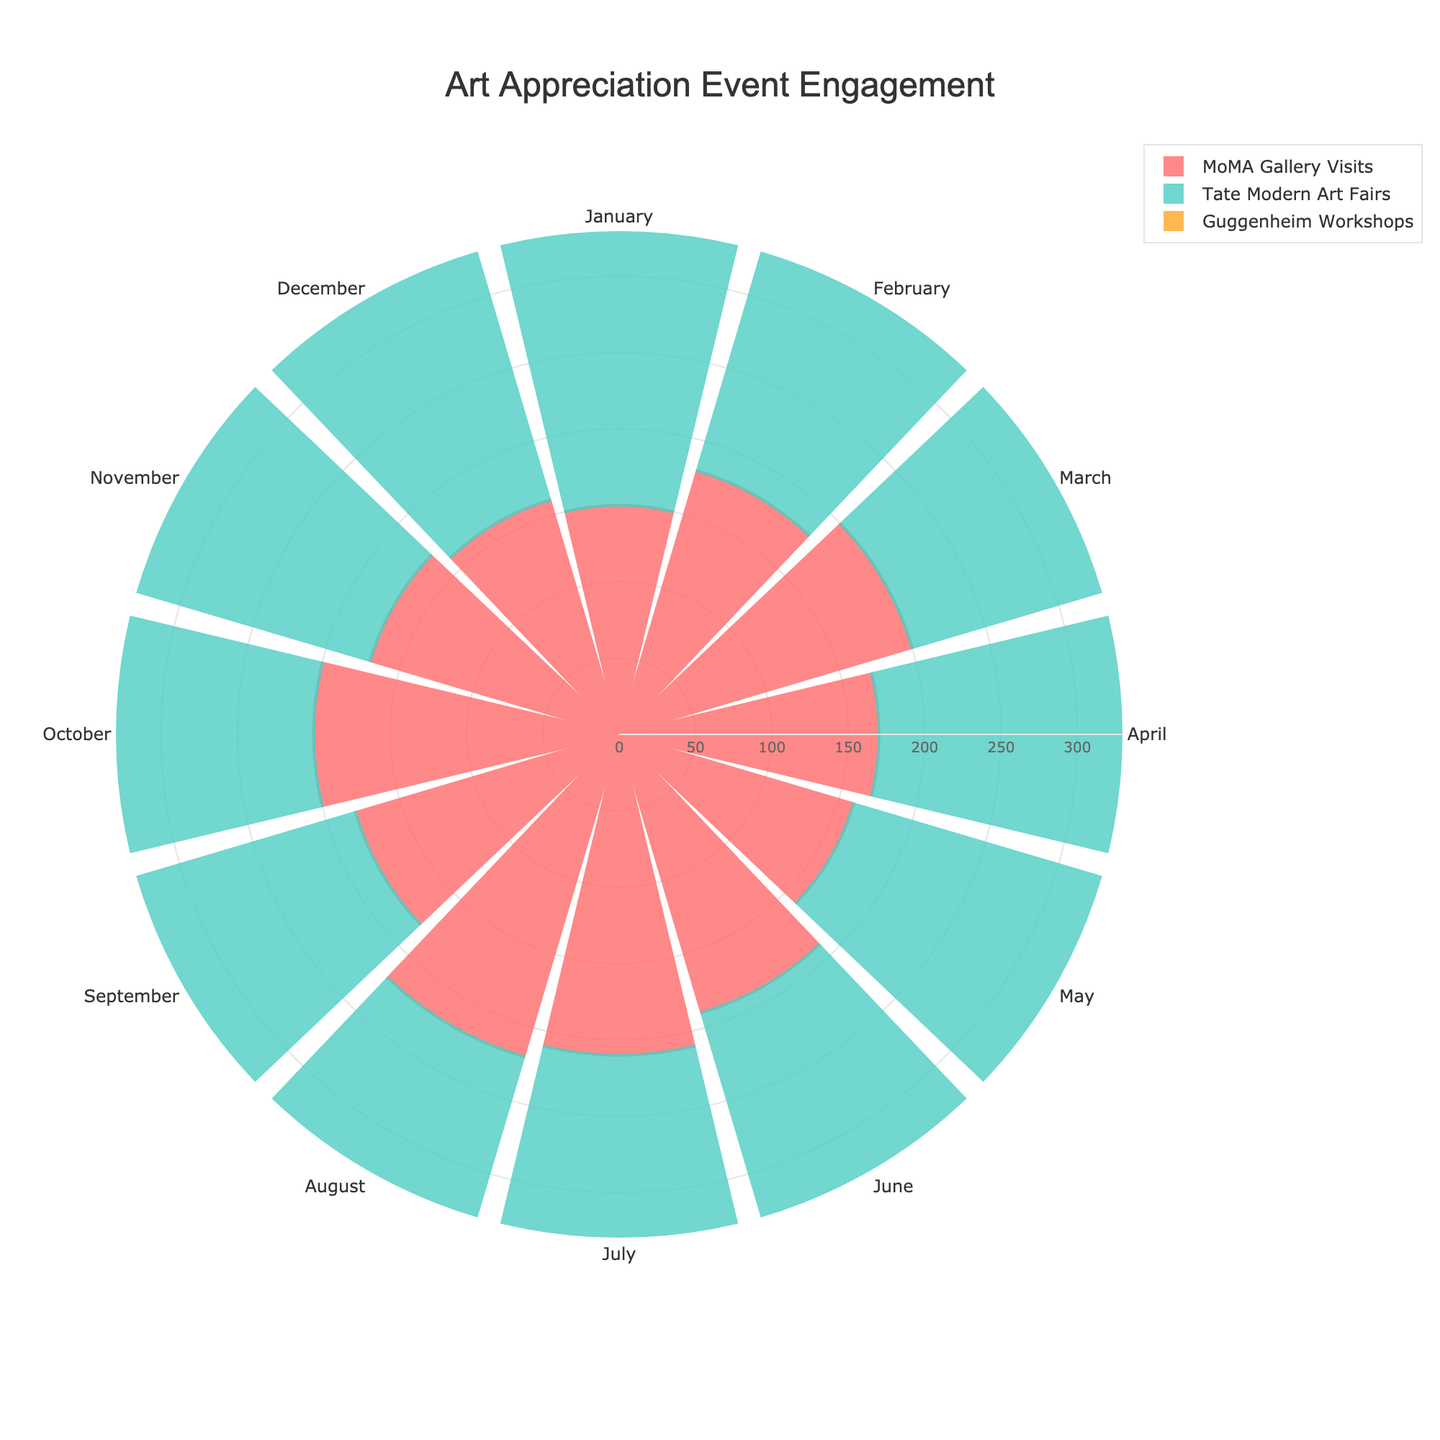1. What is the title of the figure? The title is typically displayed prominently at the top of the figure. In this case, the title is set to "Art Appreciation Event Engagement".
Answer: Art Appreciation Event Engagement 2. Which event had the highest engagement level in August? By looking at the radial distance for August, the longest bar represents the 'Tate Modern Art Fairs'.
Answer: Tate Modern Art Fairs 3. How many groups or categories are there in this rose chart? The rose chart shows three groups: 'MoMA Gallery Visits', 'Tate Modern Art Fairs', and 'Guggenheim Workshops'.
Answer: 3 4. What is the color used to represent 'MoMA Gallery Visits'? The bar representing 'MoMA Gallery Visits' uses a red color.
Answer: Red 5. Which month had the lowest engagement in 'Guggenheim Workshops'? By comparing the radial lengths for each month within the 'Guggenheim Workshops' group, January shows the smallest bar.
Answer: January 6. What is the total engagement level for 'MoMA Gallery Visits' in the first quarter (January to March)? Sum the values for 'MoMA Gallery Visits' in January (150), February (180), and March (200). The total is 150 + 180 + 200 = 530.
Answer: 530 7. During which months did 'Tate Modern Art Fairs' have more than 250 participants? Check the radial lengths for 'Tate Modern Art Fairs' and note the months with bars exceeding 250: April, May, June, July, and August.
Answer: April, May, June, July, August 8. Compare the engagement levels between 'Guggenheim Workshops' and 'MoMA Gallery Visits' in October. Which one is higher, and by how much? 'Guggenheim Workshops' in October has 130 participants, and 'MoMA Gallery Visits' has 200. The difference is 200 - 130 = 70.
Answer: 'MoMA Gallery Visits' by 70 9. What is the average monthly engagement for 'Tate Modern Art Fairs'? Sum the monthly engagements of 'Tate Modern Art Fairs' and divide by 12: (240 + 220 + 230 + 250 + 260 + 280 + 290 + 300 + 270 + 260 + 240 + 230) / 12 = 259.17.
Answer: 259.17 10. Which event shows a consistent increasing trend from January to December? By observing each group's bars from January to December, 'Guggenheim Workshops' consistently increases its participants month by month.
Answer: Guggenheim Workshops 